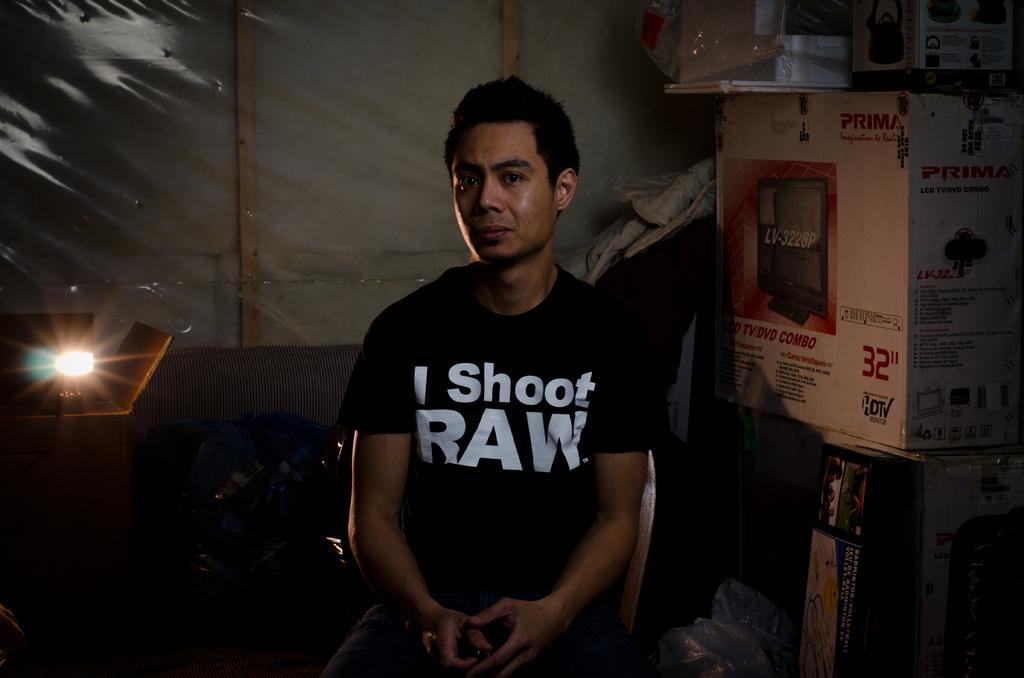Can you describe this image briefly? In this picture I can see a man seated on the chair and I can see few carton boxes on the table and a light on the left side table. 